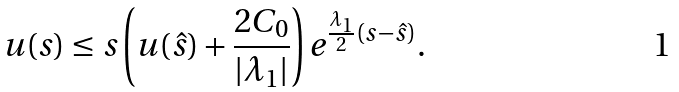Convert formula to latex. <formula><loc_0><loc_0><loc_500><loc_500>u ( s ) \leq s \left ( u ( \hat { s } ) + \frac { 2 C _ { 0 } } { | \lambda _ { 1 } | } \right ) e ^ { \frac { \lambda _ { 1 } } { 2 } ( s - \hat { s } ) } .</formula> 